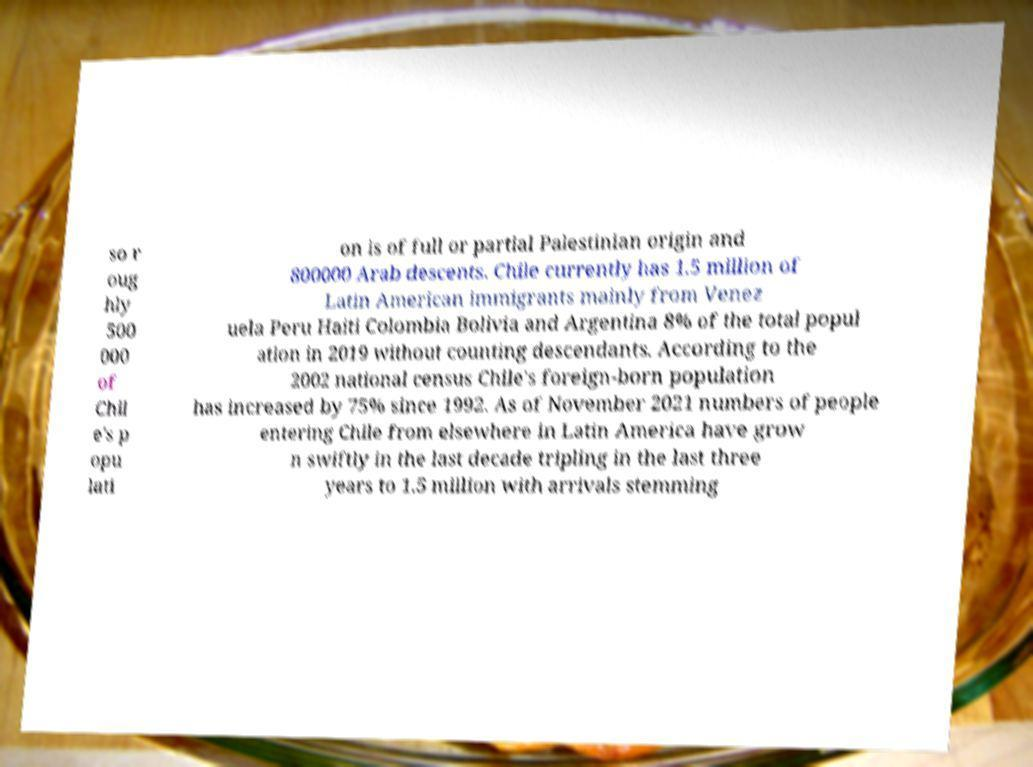Please read and relay the text visible in this image. What does it say? so r oug hly 500 000 of Chil e's p opu lati on is of full or partial Palestinian origin and 800000 Arab descents. Chile currently has 1.5 million of Latin American immigrants mainly from Venez uela Peru Haiti Colombia Bolivia and Argentina 8% of the total popul ation in 2019 without counting descendants. According to the 2002 national census Chile's foreign-born population has increased by 75% since 1992. As of November 2021 numbers of people entering Chile from elsewhere in Latin America have grow n swiftly in the last decade tripling in the last three years to 1.5 million with arrivals stemming 